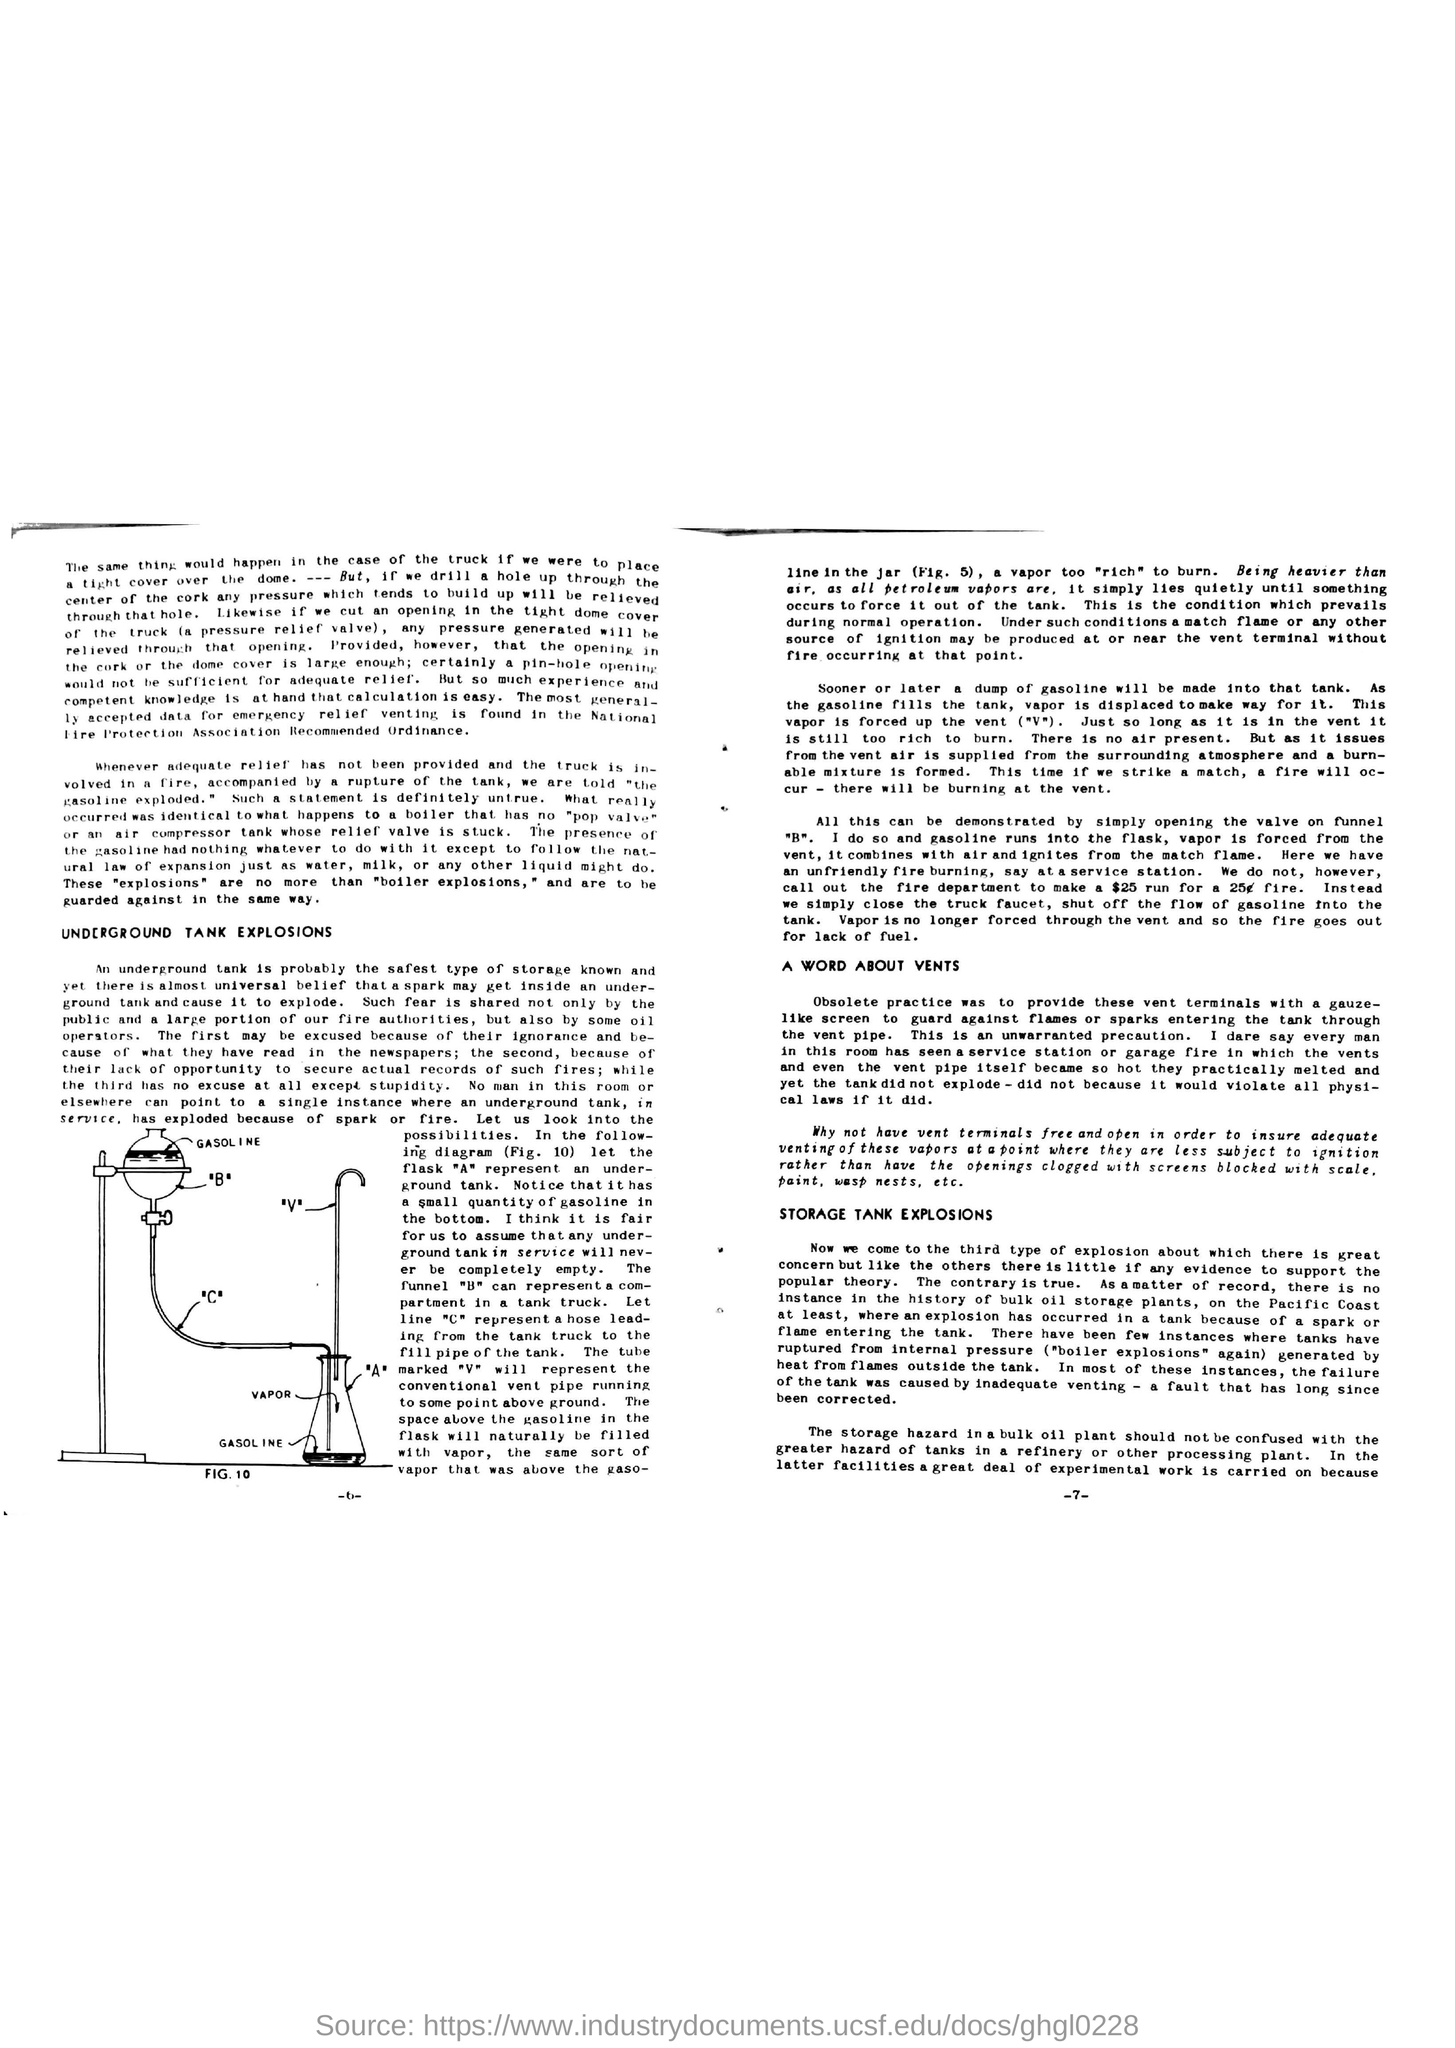Where is the most generally accepted data for emrgency relief venting is found?
Give a very brief answer. National Fire Protection Association Recommended Ordinance. Which is the safest type of storage known?
Offer a very short reply. Underground tank. 